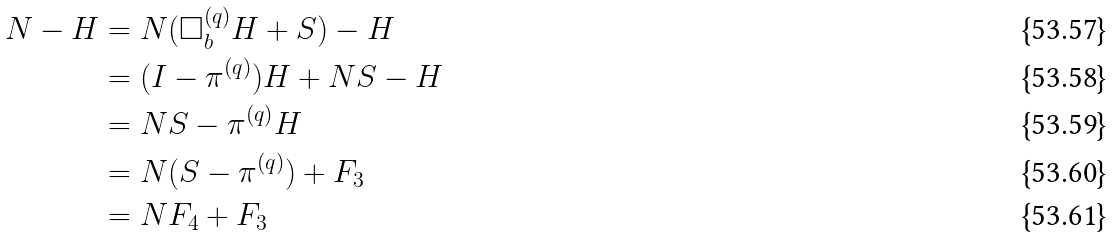<formula> <loc_0><loc_0><loc_500><loc_500>N - H & = N ( \Box ^ { ( q ) } _ { b } H + S ) - H \\ & = ( I - \pi ^ { ( q ) } ) H + N S - H \\ & = N S - \pi ^ { ( q ) } H \\ & = N ( S - \pi ^ { ( q ) } ) + F _ { 3 } \\ & = N F _ { 4 } + F _ { 3 }</formula> 